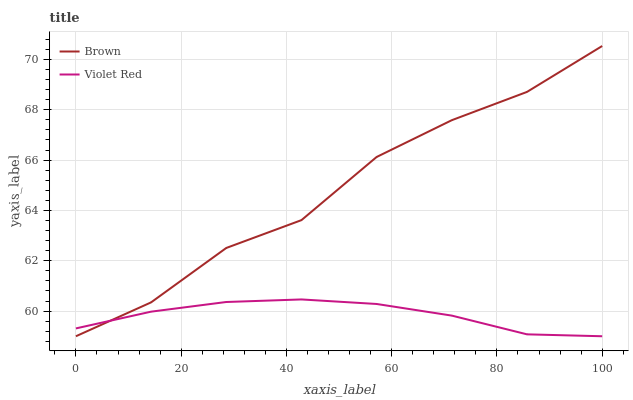Does Violet Red have the minimum area under the curve?
Answer yes or no. Yes. Does Brown have the maximum area under the curve?
Answer yes or no. Yes. Does Violet Red have the maximum area under the curve?
Answer yes or no. No. Is Violet Red the smoothest?
Answer yes or no. Yes. Is Brown the roughest?
Answer yes or no. Yes. Is Violet Red the roughest?
Answer yes or no. No. Does Brown have the lowest value?
Answer yes or no. Yes. Does Brown have the highest value?
Answer yes or no. Yes. Does Violet Red have the highest value?
Answer yes or no. No. Does Brown intersect Violet Red?
Answer yes or no. Yes. Is Brown less than Violet Red?
Answer yes or no. No. Is Brown greater than Violet Red?
Answer yes or no. No. 